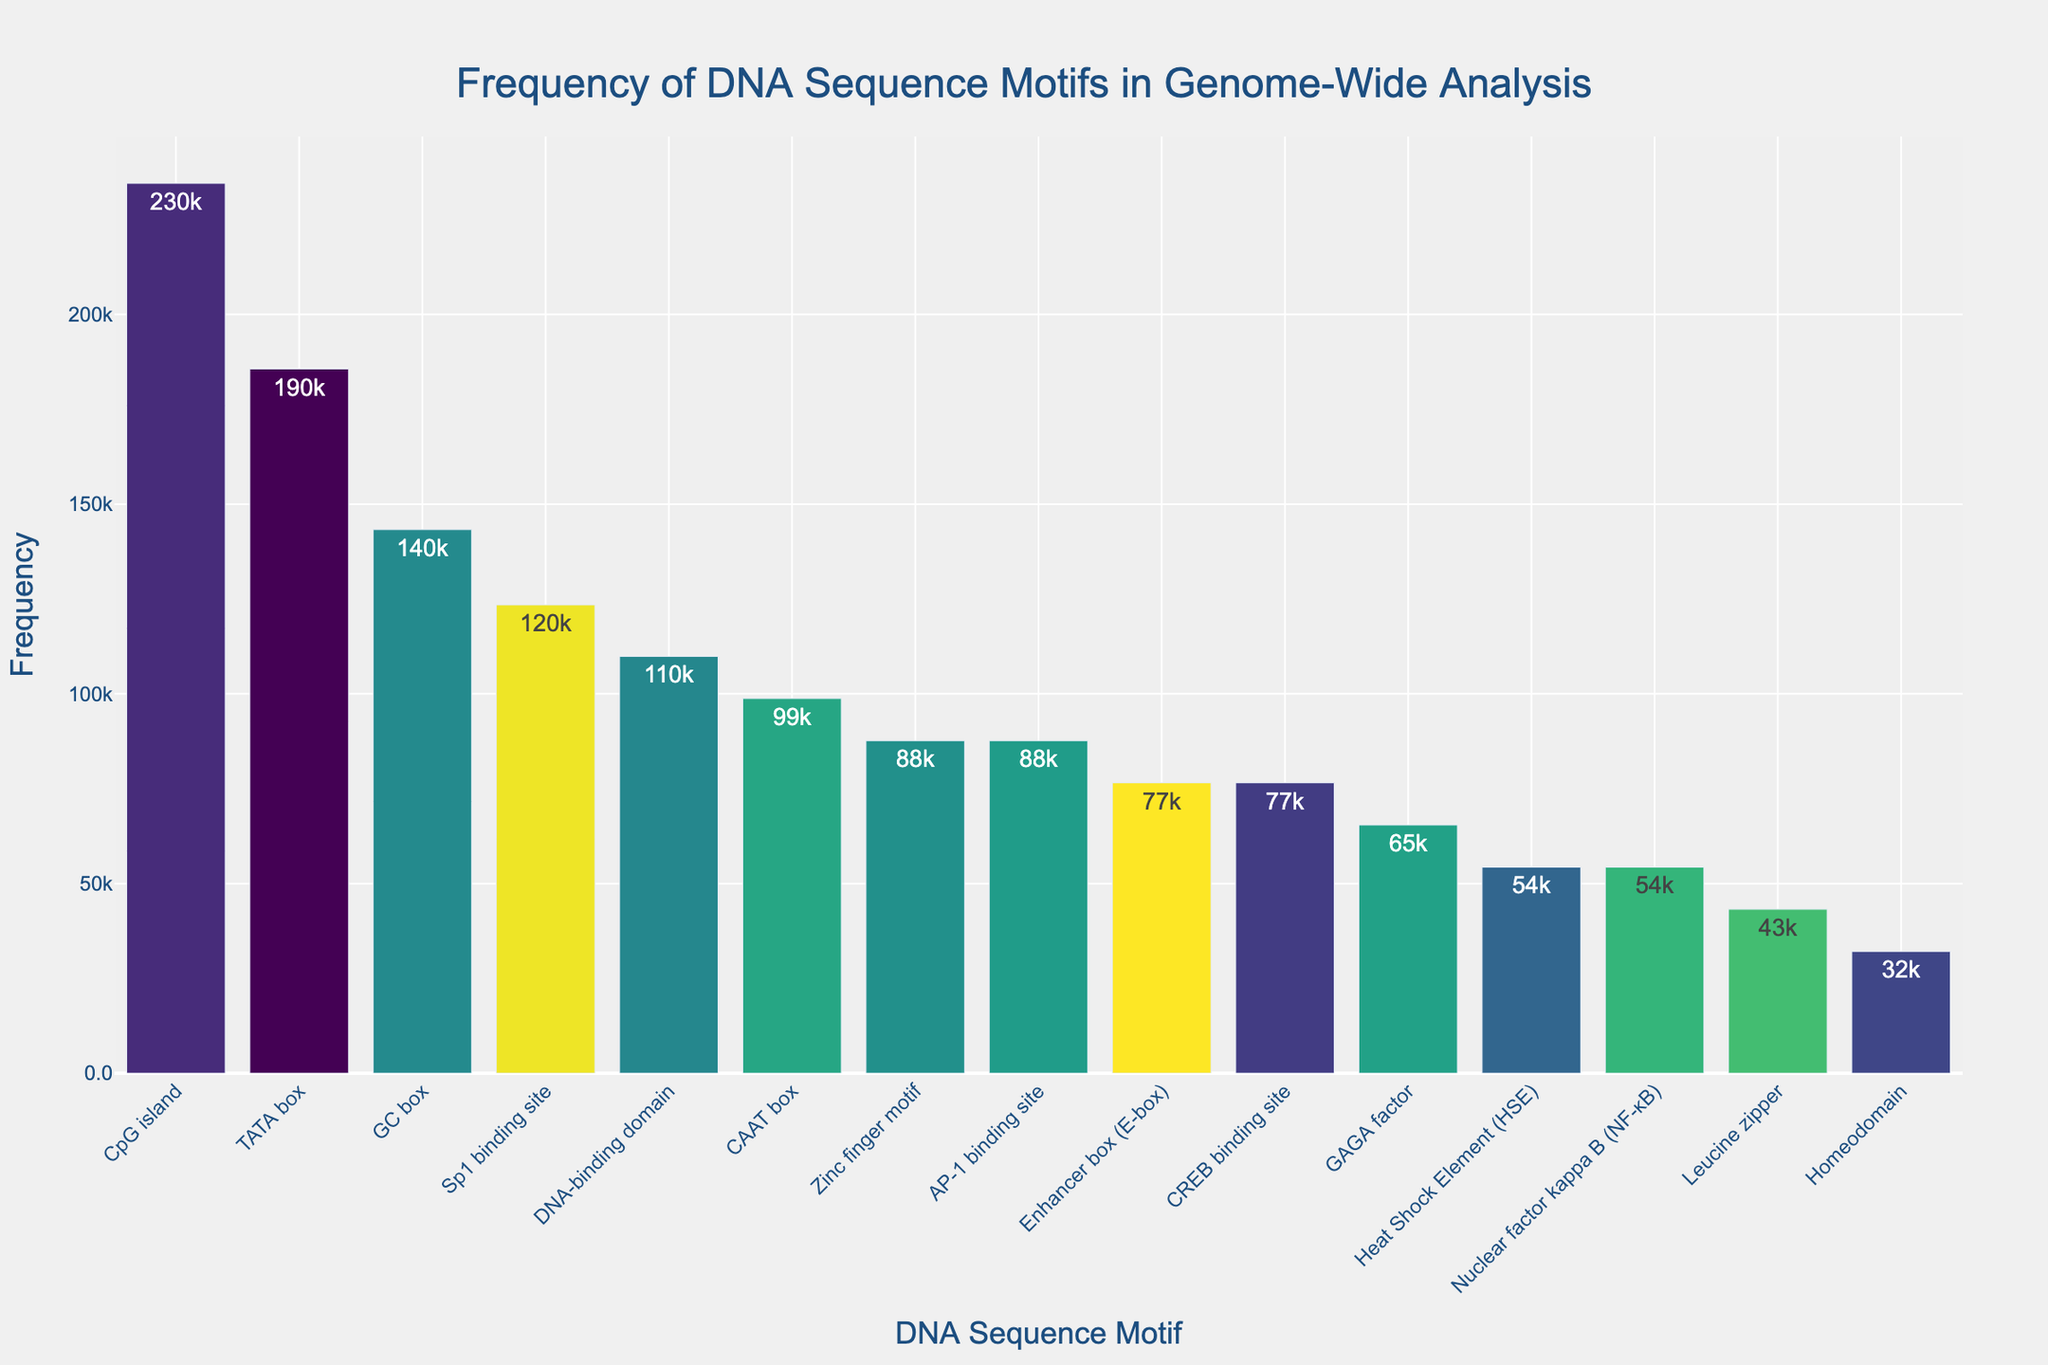What's the most frequent DNA sequence motif? The title indicates that the y-axis represents the frequency. By inspecting the bar heights, the CpG island motif has the highest bar, indicating it's the most frequent.
Answer: CpG island How many DNA sequence motifs are shown in the figure? The x-axis labels represent the individual motifs. By counting the number of unique labels on the x-axis, we find there are 15 motifs.
Answer: 15 Which motif has the lowest frequency? The y-axis represents frequency. Looking at the shortest bar, the Leucine zipper motif has the lowest frequency.
Answer: Leucine zipper What is the sum of the frequencies of the TATA box and GC box motifs? The frequencies are provided in the hover text for each bar. Summing the frequencies of TATA box (185632) and GC box (143289): 185632 + 143289 = 328921.
Answer: 328921 Is the frequency of the Sp1 binding site greater than that of the AP-1 binding site? By comparing the heights of the bars for Sp1 binding site (123456) and AP-1 binding site (87654), the Sp1 binding site is higher, indicating its frequency is greater.
Answer: Yes Which motif has a frequency closest to 75000? Inspecting the bars around the frequency of 75000, the motif with a frequency close to it is the CREB binding site with a frequency of 76543.
Answer: CREB binding site What is the average frequency of the Zinc finger motif, Leucine zipper, and Homeodomain motifs? Sum the frequencies of Zinc finger motif (87654), Leucine zipper (43210), and Homeodomain (32109): 87654 + 43210 + 32109 = 162973. Divide by 3 (number of motifs): 162973 / 3 ≈ 54324.33.
Answer: 54324.33 Which motif's frequency is exactly twice that of the Heat Shock Element (HSE)? The frequency of HSE is 54321. Double it is 108642. The motif with a frequency closest to 108642 is DNA-binding domain (109876).
Answer: DNA-binding domain How many motifs have a frequency greater than 100000? Count the number of bars with frequencies over 100000. These are TATA box (185632), GC box (143289), CpG island (234567), DNA-binding domain (109876), and Sp1 binding site (123456), totaling 5 motifs.
Answer: 5 What's the ratio of the frequency of the E-box to the CAAT box? The frequency of the E-box is 76543 and that of the CAAT box is 98765. The ratio is calculated as 76543 / 98765 ≈ 0.775.
Answer: 0.775 